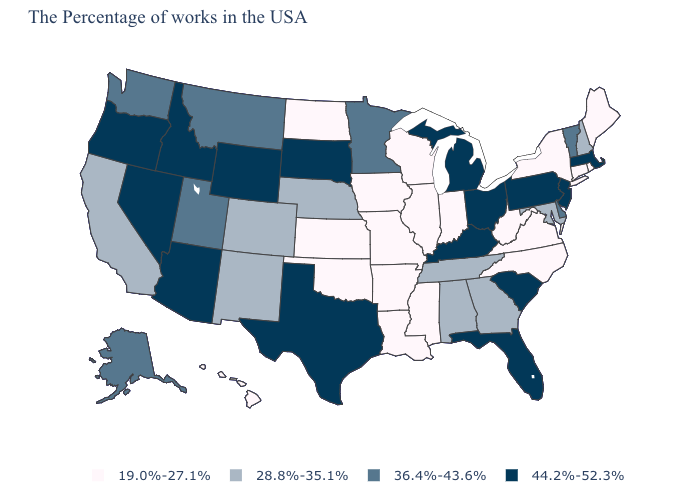What is the lowest value in the Northeast?
Be succinct. 19.0%-27.1%. Among the states that border Arizona , which have the highest value?
Write a very short answer. Nevada. What is the value of Massachusetts?
Be succinct. 44.2%-52.3%. Does the map have missing data?
Give a very brief answer. No. Which states have the highest value in the USA?
Be succinct. Massachusetts, New Jersey, Pennsylvania, South Carolina, Ohio, Florida, Michigan, Kentucky, Texas, South Dakota, Wyoming, Arizona, Idaho, Nevada, Oregon. What is the value of South Carolina?
Keep it brief. 44.2%-52.3%. Name the states that have a value in the range 28.8%-35.1%?
Keep it brief. New Hampshire, Maryland, Georgia, Alabama, Tennessee, Nebraska, Colorado, New Mexico, California. What is the value of Kansas?
Short answer required. 19.0%-27.1%. What is the value of Illinois?
Short answer required. 19.0%-27.1%. What is the value of Texas?
Quick response, please. 44.2%-52.3%. Does the map have missing data?
Give a very brief answer. No. What is the value of Texas?
Write a very short answer. 44.2%-52.3%. Name the states that have a value in the range 28.8%-35.1%?
Give a very brief answer. New Hampshire, Maryland, Georgia, Alabama, Tennessee, Nebraska, Colorado, New Mexico, California. 